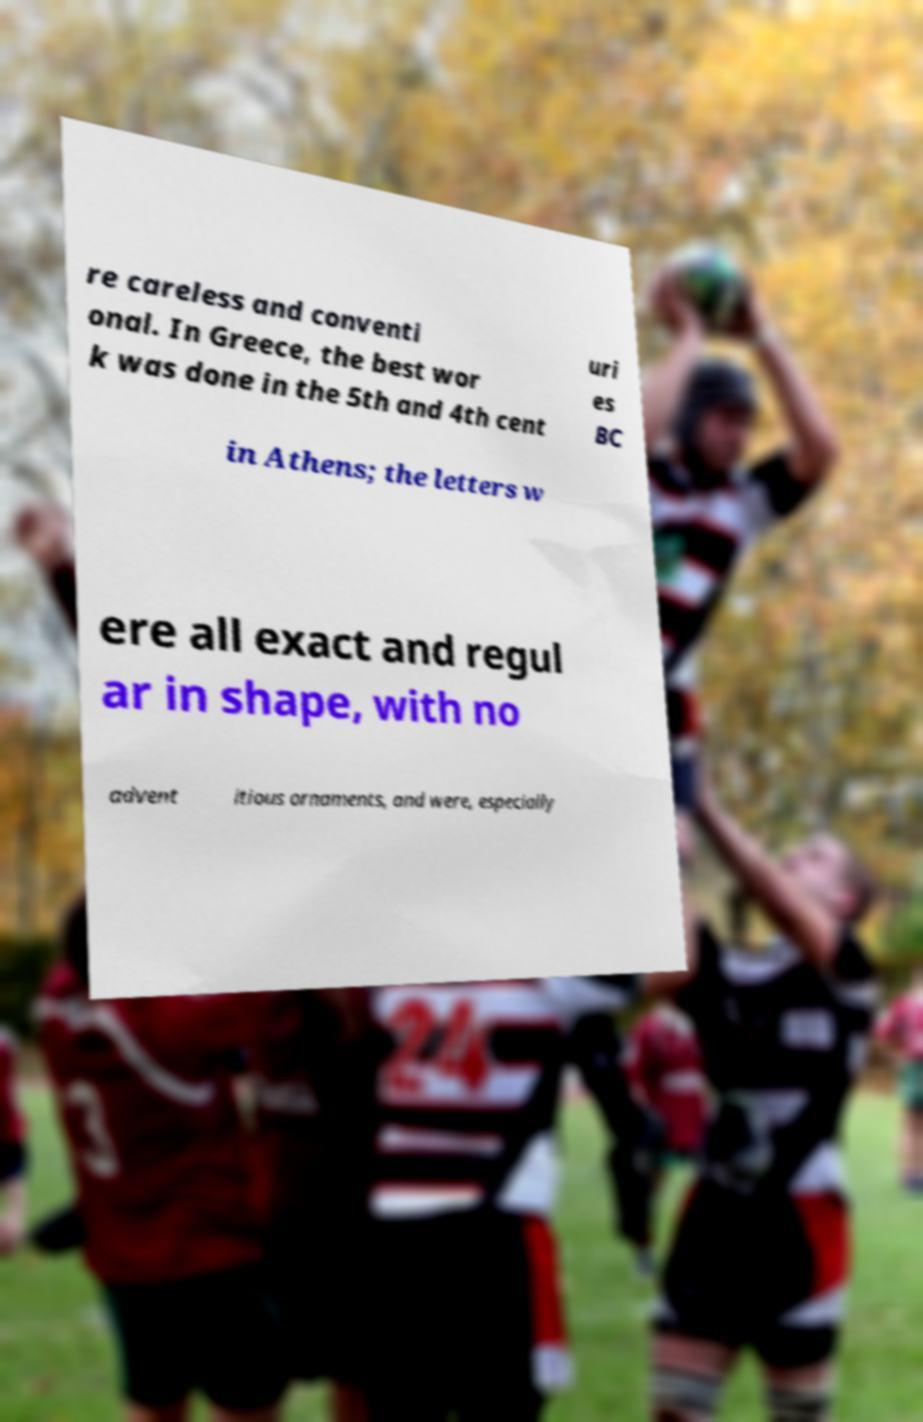There's text embedded in this image that I need extracted. Can you transcribe it verbatim? re careless and conventi onal. In Greece, the best wor k was done in the 5th and 4th cent uri es BC in Athens; the letters w ere all exact and regul ar in shape, with no advent itious ornaments, and were, especially 